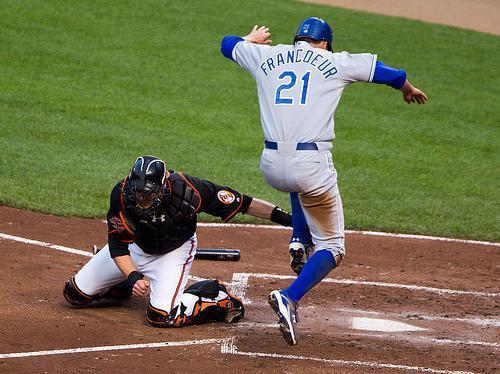How many players are pictured here?
Give a very brief answer. 2. 